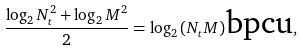<formula> <loc_0><loc_0><loc_500><loc_500>\frac { \log _ { 2 } N _ { t } ^ { 2 } + \log _ { 2 } M ^ { 2 } } { 2 } = \log _ { 2 } { ( N _ { t } M ) } \text {bpcu} ,</formula> 